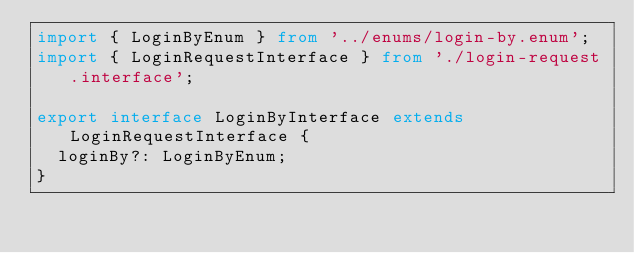<code> <loc_0><loc_0><loc_500><loc_500><_TypeScript_>import { LoginByEnum } from '../enums/login-by.enum';
import { LoginRequestInterface } from './login-request.interface';

export interface LoginByInterface extends LoginRequestInterface {
  loginBy?: LoginByEnum;
}
</code> 